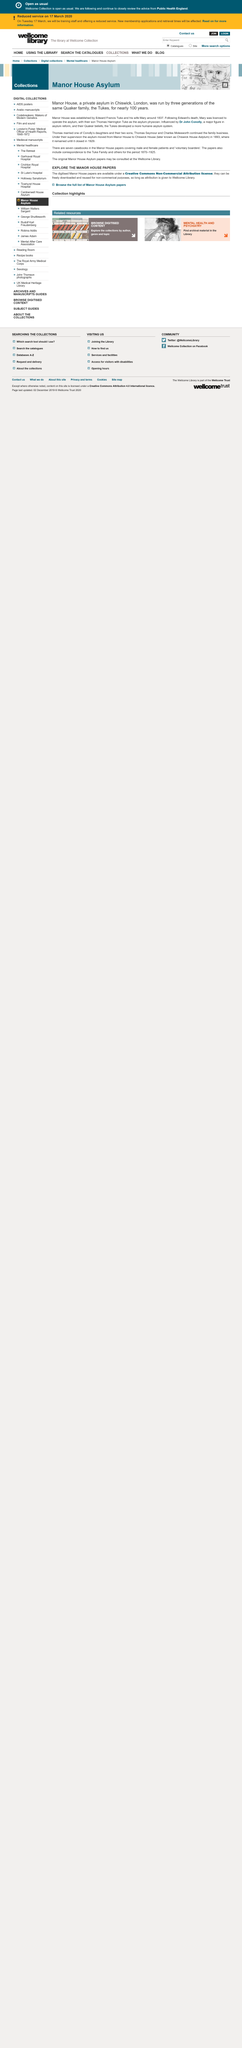Draw attention to some important aspects in this diagram. The asylum was run for nearly 100 years. Dr. John Conolly influenced the asylum. The location of Manor House is Chiswick, London, which is a well-known place among the people. 